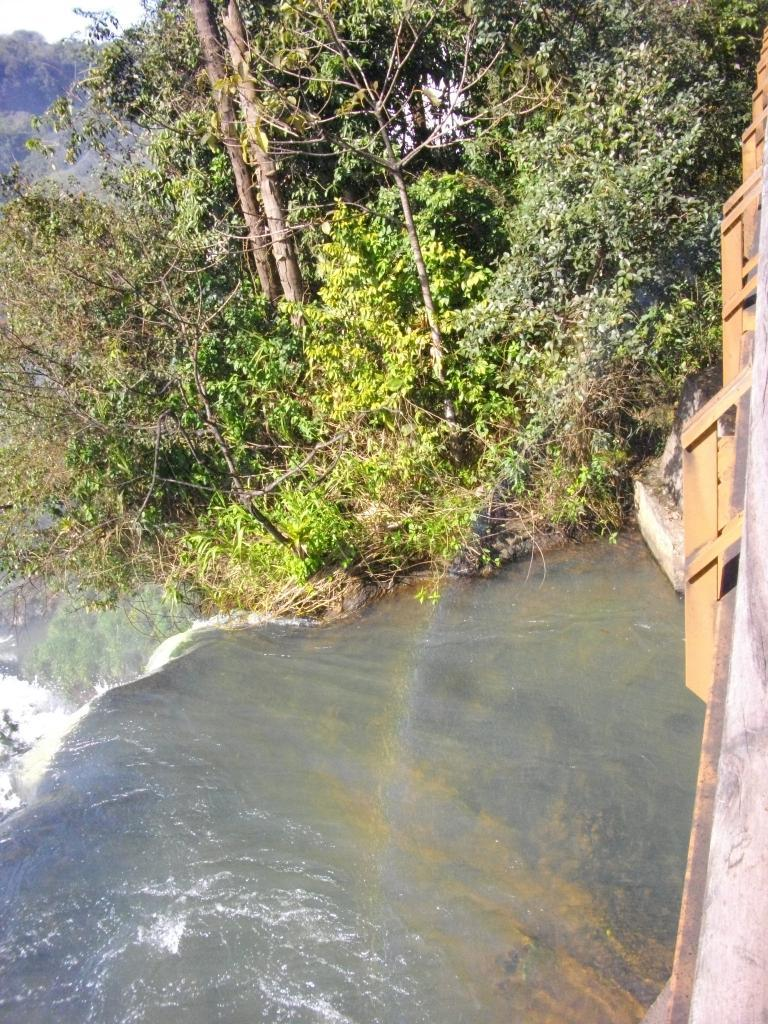What can be seen in the image that is related to nature? There are trees visible in the image. What else is present in the image besides trees? There is water visible in the image, as well as an unspecified object. What type of voice can be heard coming from the zebra in the image? There is no zebra present in the image, so it is not possible to determine what, if any, voice might be heard. 